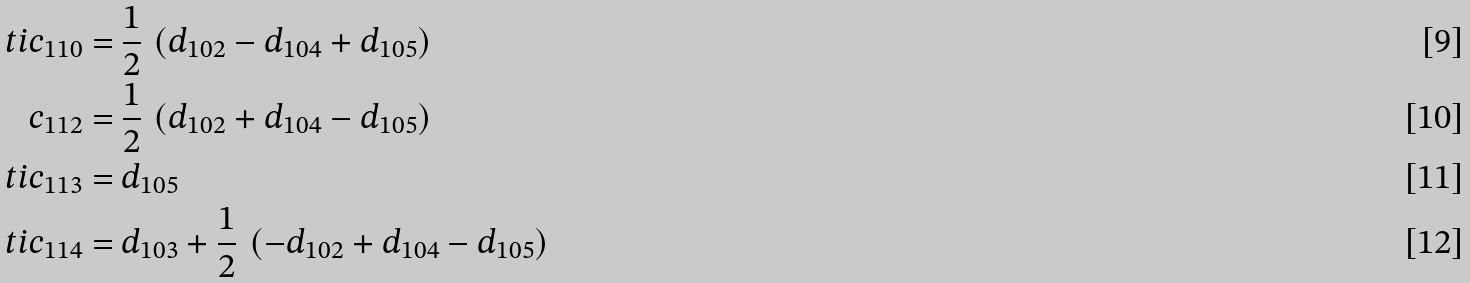<formula> <loc_0><loc_0><loc_500><loc_500>\ t i { c } _ { 1 1 0 } = & \ \frac { 1 } { 2 } \, \left ( d _ { 1 0 2 } - d _ { 1 0 4 } + d _ { 1 0 5 } \right ) \\ c _ { 1 1 2 } = & \ \frac { 1 } { 2 } \, \left ( d _ { 1 0 2 } + d _ { 1 0 4 } - d _ { 1 0 5 } \right ) \\ \ t i { c } _ { 1 1 3 } = & \ d _ { 1 0 5 } \\ \ t i { c } _ { 1 1 4 } = & \ d _ { 1 0 3 } + \frac { 1 } { 2 } \, \left ( - d _ { 1 0 2 } + d _ { 1 0 4 } - d _ { 1 0 5 } \right )</formula> 